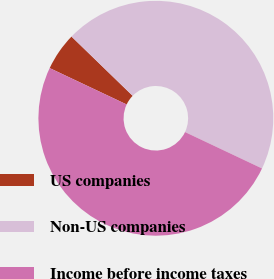Convert chart. <chart><loc_0><loc_0><loc_500><loc_500><pie_chart><fcel>US companies<fcel>Non-US companies<fcel>Income before income taxes<nl><fcel>5.22%<fcel>44.78%<fcel>50.0%<nl></chart> 